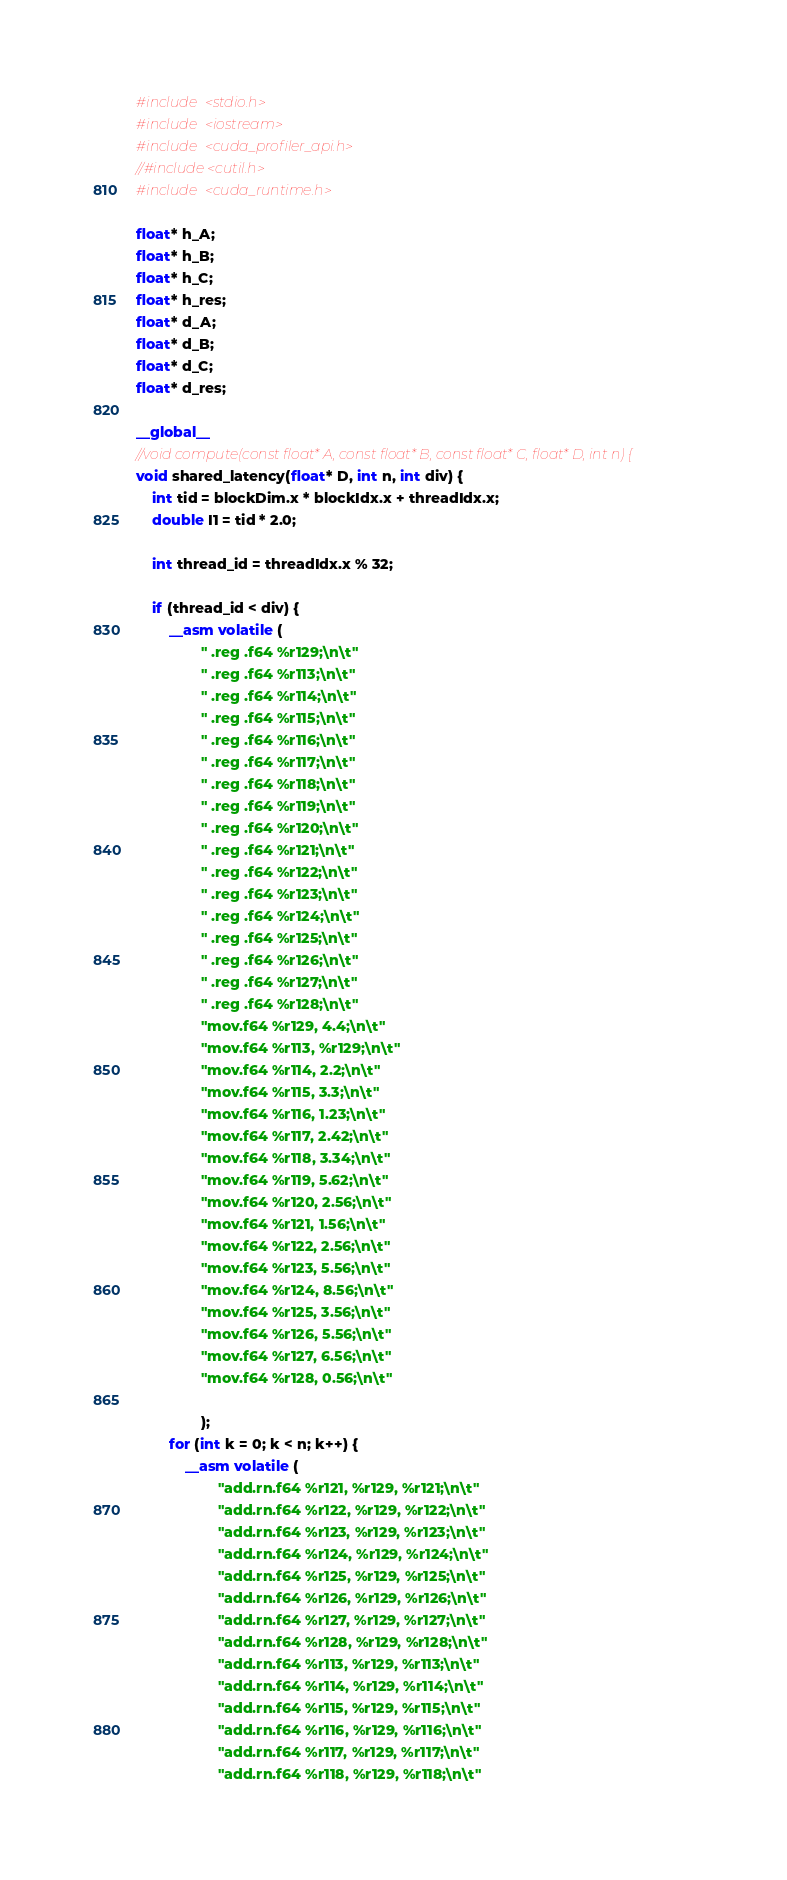<code> <loc_0><loc_0><loc_500><loc_500><_Cuda_>#include <stdio.h>
#include <iostream>
#include <cuda_profiler_api.h>
//#include <cutil.h>
#include <cuda_runtime.h>

float* h_A;
float* h_B;
float* h_C;
float* h_res;
float* d_A;
float* d_B;
float* d_C;
float* d_res;

__global__
//void compute(const float* A, const float* B, const float* C, float* D, int n) {
void shared_latency(float* D, int n, int div) {
    int tid = blockDim.x * blockIdx.x + threadIdx.x;
    double I1 = tid * 2.0;

    int thread_id = threadIdx.x % 32;

    if (thread_id < div) {
        __asm volatile (
                " .reg .f64 %r129;\n\t"
                " .reg .f64 %r113;\n\t"
                " .reg .f64 %r114;\n\t"
                " .reg .f64 %r115;\n\t"
                " .reg .f64 %r116;\n\t"
                " .reg .f64 %r117;\n\t"
                " .reg .f64 %r118;\n\t"
                " .reg .f64 %r119;\n\t"
                " .reg .f64 %r120;\n\t"
                " .reg .f64 %r121;\n\t"
                " .reg .f64 %r122;\n\t"
                " .reg .f64 %r123;\n\t"
                " .reg .f64 %r124;\n\t"
                " .reg .f64 %r125;\n\t"
                " .reg .f64 %r126;\n\t"
                " .reg .f64 %r127;\n\t"
                " .reg .f64 %r128;\n\t"
                "mov.f64 %r129, 4.4;\n\t"
                "mov.f64 %r113, %r129;\n\t"
                "mov.f64 %r114, 2.2;\n\t"
                "mov.f64 %r115, 3.3;\n\t"
                "mov.f64 %r116, 1.23;\n\t"
                "mov.f64 %r117, 2.42;\n\t"
                "mov.f64 %r118, 3.34;\n\t"
                "mov.f64 %r119, 5.62;\n\t"
                "mov.f64 %r120, 2.56;\n\t"
                "mov.f64 %r121, 1.56;\n\t"
                "mov.f64 %r122, 2.56;\n\t"
                "mov.f64 %r123, 5.56;\n\t"
                "mov.f64 %r124, 8.56;\n\t"
                "mov.f64 %r125, 3.56;\n\t"
                "mov.f64 %r126, 5.56;\n\t"
                "mov.f64 %r127, 6.56;\n\t"
                "mov.f64 %r128, 0.56;\n\t"

                );
        for (int k = 0; k < n; k++) {
            __asm volatile (
                    "add.rn.f64 %r121, %r129, %r121;\n\t" 
                    "add.rn.f64 %r122, %r129, %r122;\n\t" 
                    "add.rn.f64 %r123, %r129, %r123;\n\t" 
                    "add.rn.f64 %r124, %r129, %r124;\n\t" 
                    "add.rn.f64 %r125, %r129, %r125;\n\t" 
                    "add.rn.f64 %r126, %r129, %r126;\n\t" 
                    "add.rn.f64 %r127, %r129, %r127;\n\t" 
                    "add.rn.f64 %r128, %r129, %r128;\n\t" 
                    "add.rn.f64 %r113, %r129, %r113;\n\t" 
                    "add.rn.f64 %r114, %r129, %r114;\n\t" 
                    "add.rn.f64 %r115, %r129, %r115;\n\t" 
                    "add.rn.f64 %r116, %r129, %r116;\n\t" 
                    "add.rn.f64 %r117, %r129, %r117;\n\t" 
                    "add.rn.f64 %r118, %r129, %r118;\n\t" </code> 